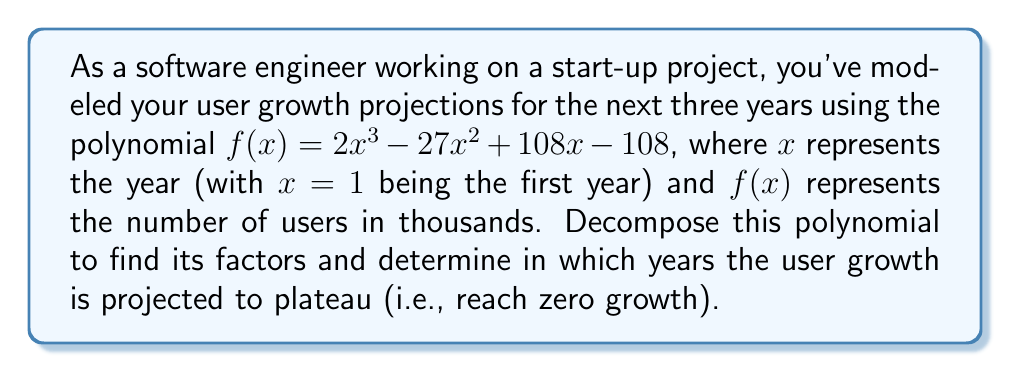Can you answer this question? Let's approach this step-by-step:

1) First, we need to factor the polynomial $f(x) = 2x^3 - 27x^2 + 108x - 108$.

2) We can start by factoring out the greatest common factor (GCF):
   $f(x) = 2(x^3 - \frac{27}{2}x^2 + 54x - 54)$

3) The polynomial inside the parentheses looks like it might have a factor of $(x - 3)$. Let's use polynomial long division to check:

   $$\begin{array}{r}
   x^2 - \frac{21}{2}x + 18 \\
   x - 3 \enclose{longdiv}{x^3 - \frac{27}{2}x^2 + 54x - 54} \\
   \underline{x^3 - 3x^2} \\
   \frac{-21}{2}x^2 + 54x \\
   \underline{\frac{-21}{2}x^2 + \frac{63}{2}x} \\
   \frac{45}{2}x - 54 \\
   \underline{\frac{45}{2}x - \frac{135}{2}} \\
   0
   \end{array}$$

4) The division results in no remainder, confirming that $(x - 3)$ is indeed a factor.

5) Now we can write: $f(x) = 2(x - 3)(x^2 - \frac{21}{2}x + 18)$

6) The quadratic factor can be further factored:
   $x^2 - \frac{21}{2}x + 18 = (x - 6)(x - \frac{3}{2})$

7) Therefore, the fully factored polynomial is:
   $f(x) = 2(x - 3)(x - 6)(x - \frac{3}{2})$

8) The roots of this polynomial (where $f(x) = 0$) are at $x = 3$, $x = 6$, and $x = \frac{3}{2}$.

9) However, the question asks for years when growth plateaus, which occurs when the derivative $f'(x) = 0$. The derivative is:
   $f'(x) = 6x^2 - 54x + 108$

10) Factoring $f'(x)$:
    $f'(x) = 6(x^2 - 9x + 18) = 6(x - 3)(x - 6)$

11) The derivative is zero when $x = 3$ or $x = 6$, corresponding to the 3rd and 6th years.

Therefore, the user growth is projected to plateau in the 3rd and 6th years.
Answer: 3rd and 6th years 